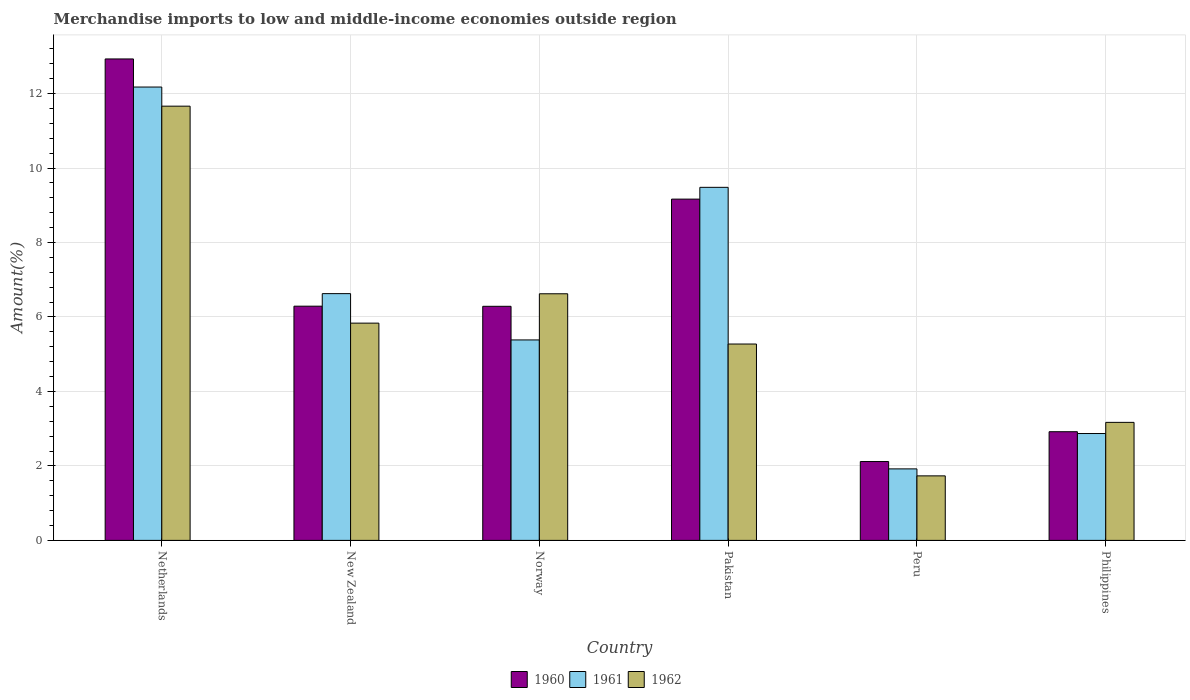How many groups of bars are there?
Make the answer very short. 6. Are the number of bars per tick equal to the number of legend labels?
Your response must be concise. Yes. Are the number of bars on each tick of the X-axis equal?
Make the answer very short. Yes. How many bars are there on the 5th tick from the right?
Your answer should be very brief. 3. In how many cases, is the number of bars for a given country not equal to the number of legend labels?
Your answer should be very brief. 0. What is the percentage of amount earned from merchandise imports in 1960 in Netherlands?
Provide a succinct answer. 12.93. Across all countries, what is the maximum percentage of amount earned from merchandise imports in 1961?
Make the answer very short. 12.18. Across all countries, what is the minimum percentage of amount earned from merchandise imports in 1962?
Ensure brevity in your answer.  1.73. What is the total percentage of amount earned from merchandise imports in 1961 in the graph?
Provide a short and direct response. 38.46. What is the difference between the percentage of amount earned from merchandise imports in 1962 in New Zealand and that in Philippines?
Your answer should be compact. 2.67. What is the difference between the percentage of amount earned from merchandise imports in 1961 in Norway and the percentage of amount earned from merchandise imports in 1962 in Philippines?
Provide a short and direct response. 2.21. What is the average percentage of amount earned from merchandise imports in 1962 per country?
Make the answer very short. 5.72. What is the difference between the percentage of amount earned from merchandise imports of/in 1962 and percentage of amount earned from merchandise imports of/in 1960 in Peru?
Offer a very short reply. -0.39. In how many countries, is the percentage of amount earned from merchandise imports in 1962 greater than 9.6 %?
Keep it short and to the point. 1. What is the ratio of the percentage of amount earned from merchandise imports in 1962 in New Zealand to that in Norway?
Your answer should be compact. 0.88. Is the percentage of amount earned from merchandise imports in 1961 in New Zealand less than that in Pakistan?
Provide a succinct answer. Yes. What is the difference between the highest and the second highest percentage of amount earned from merchandise imports in 1960?
Make the answer very short. -3.76. What is the difference between the highest and the lowest percentage of amount earned from merchandise imports in 1960?
Your answer should be compact. 10.81. In how many countries, is the percentage of amount earned from merchandise imports in 1961 greater than the average percentage of amount earned from merchandise imports in 1961 taken over all countries?
Your response must be concise. 3. What does the 2nd bar from the left in Philippines represents?
Your answer should be compact. 1961. Is it the case that in every country, the sum of the percentage of amount earned from merchandise imports in 1961 and percentage of amount earned from merchandise imports in 1962 is greater than the percentage of amount earned from merchandise imports in 1960?
Provide a succinct answer. Yes. How many bars are there?
Make the answer very short. 18. Does the graph contain grids?
Offer a very short reply. Yes. Where does the legend appear in the graph?
Your answer should be compact. Bottom center. What is the title of the graph?
Your answer should be compact. Merchandise imports to low and middle-income economies outside region. Does "1983" appear as one of the legend labels in the graph?
Provide a succinct answer. No. What is the label or title of the Y-axis?
Provide a short and direct response. Amount(%). What is the Amount(%) in 1960 in Netherlands?
Ensure brevity in your answer.  12.93. What is the Amount(%) of 1961 in Netherlands?
Make the answer very short. 12.18. What is the Amount(%) of 1962 in Netherlands?
Your response must be concise. 11.66. What is the Amount(%) of 1960 in New Zealand?
Your answer should be very brief. 6.29. What is the Amount(%) of 1961 in New Zealand?
Give a very brief answer. 6.63. What is the Amount(%) in 1962 in New Zealand?
Make the answer very short. 5.83. What is the Amount(%) of 1960 in Norway?
Your response must be concise. 6.29. What is the Amount(%) of 1961 in Norway?
Give a very brief answer. 5.38. What is the Amount(%) of 1962 in Norway?
Ensure brevity in your answer.  6.62. What is the Amount(%) in 1960 in Pakistan?
Ensure brevity in your answer.  9.17. What is the Amount(%) in 1961 in Pakistan?
Provide a succinct answer. 9.48. What is the Amount(%) in 1962 in Pakistan?
Ensure brevity in your answer.  5.27. What is the Amount(%) of 1960 in Peru?
Ensure brevity in your answer.  2.12. What is the Amount(%) of 1961 in Peru?
Provide a short and direct response. 1.92. What is the Amount(%) of 1962 in Peru?
Your answer should be very brief. 1.73. What is the Amount(%) of 1960 in Philippines?
Keep it short and to the point. 2.92. What is the Amount(%) in 1961 in Philippines?
Provide a short and direct response. 2.87. What is the Amount(%) of 1962 in Philippines?
Ensure brevity in your answer.  3.17. Across all countries, what is the maximum Amount(%) in 1960?
Give a very brief answer. 12.93. Across all countries, what is the maximum Amount(%) in 1961?
Ensure brevity in your answer.  12.18. Across all countries, what is the maximum Amount(%) of 1962?
Give a very brief answer. 11.66. Across all countries, what is the minimum Amount(%) of 1960?
Offer a very short reply. 2.12. Across all countries, what is the minimum Amount(%) in 1961?
Give a very brief answer. 1.92. Across all countries, what is the minimum Amount(%) of 1962?
Ensure brevity in your answer.  1.73. What is the total Amount(%) of 1960 in the graph?
Your answer should be compact. 39.71. What is the total Amount(%) in 1961 in the graph?
Offer a very short reply. 38.46. What is the total Amount(%) in 1962 in the graph?
Offer a terse response. 34.3. What is the difference between the Amount(%) of 1960 in Netherlands and that in New Zealand?
Provide a succinct answer. 6.64. What is the difference between the Amount(%) of 1961 in Netherlands and that in New Zealand?
Your response must be concise. 5.55. What is the difference between the Amount(%) in 1962 in Netherlands and that in New Zealand?
Make the answer very short. 5.83. What is the difference between the Amount(%) of 1960 in Netherlands and that in Norway?
Offer a very short reply. 6.64. What is the difference between the Amount(%) of 1961 in Netherlands and that in Norway?
Keep it short and to the point. 6.79. What is the difference between the Amount(%) of 1962 in Netherlands and that in Norway?
Keep it short and to the point. 5.04. What is the difference between the Amount(%) of 1960 in Netherlands and that in Pakistan?
Ensure brevity in your answer.  3.76. What is the difference between the Amount(%) of 1961 in Netherlands and that in Pakistan?
Your answer should be compact. 2.69. What is the difference between the Amount(%) in 1962 in Netherlands and that in Pakistan?
Provide a succinct answer. 6.39. What is the difference between the Amount(%) of 1960 in Netherlands and that in Peru?
Your answer should be very brief. 10.81. What is the difference between the Amount(%) in 1961 in Netherlands and that in Peru?
Make the answer very short. 10.26. What is the difference between the Amount(%) in 1962 in Netherlands and that in Peru?
Make the answer very short. 9.93. What is the difference between the Amount(%) in 1960 in Netherlands and that in Philippines?
Ensure brevity in your answer.  10.01. What is the difference between the Amount(%) of 1961 in Netherlands and that in Philippines?
Provide a short and direct response. 9.31. What is the difference between the Amount(%) in 1962 in Netherlands and that in Philippines?
Ensure brevity in your answer.  8.49. What is the difference between the Amount(%) in 1960 in New Zealand and that in Norway?
Offer a very short reply. 0. What is the difference between the Amount(%) of 1961 in New Zealand and that in Norway?
Provide a short and direct response. 1.24. What is the difference between the Amount(%) of 1962 in New Zealand and that in Norway?
Your answer should be compact. -0.79. What is the difference between the Amount(%) in 1960 in New Zealand and that in Pakistan?
Give a very brief answer. -2.88. What is the difference between the Amount(%) of 1961 in New Zealand and that in Pakistan?
Offer a very short reply. -2.86. What is the difference between the Amount(%) in 1962 in New Zealand and that in Pakistan?
Your answer should be compact. 0.56. What is the difference between the Amount(%) of 1960 in New Zealand and that in Peru?
Provide a short and direct response. 4.17. What is the difference between the Amount(%) in 1961 in New Zealand and that in Peru?
Provide a succinct answer. 4.71. What is the difference between the Amount(%) of 1962 in New Zealand and that in Peru?
Your answer should be compact. 4.1. What is the difference between the Amount(%) in 1960 in New Zealand and that in Philippines?
Ensure brevity in your answer.  3.37. What is the difference between the Amount(%) of 1961 in New Zealand and that in Philippines?
Your answer should be very brief. 3.76. What is the difference between the Amount(%) of 1962 in New Zealand and that in Philippines?
Provide a short and direct response. 2.67. What is the difference between the Amount(%) of 1960 in Norway and that in Pakistan?
Your answer should be very brief. -2.88. What is the difference between the Amount(%) in 1961 in Norway and that in Pakistan?
Offer a terse response. -4.1. What is the difference between the Amount(%) in 1962 in Norway and that in Pakistan?
Your answer should be very brief. 1.35. What is the difference between the Amount(%) in 1960 in Norway and that in Peru?
Your answer should be compact. 4.17. What is the difference between the Amount(%) of 1961 in Norway and that in Peru?
Make the answer very short. 3.46. What is the difference between the Amount(%) of 1962 in Norway and that in Peru?
Ensure brevity in your answer.  4.89. What is the difference between the Amount(%) in 1960 in Norway and that in Philippines?
Your answer should be very brief. 3.37. What is the difference between the Amount(%) of 1961 in Norway and that in Philippines?
Provide a short and direct response. 2.51. What is the difference between the Amount(%) in 1962 in Norway and that in Philippines?
Provide a succinct answer. 3.45. What is the difference between the Amount(%) in 1960 in Pakistan and that in Peru?
Offer a terse response. 7.05. What is the difference between the Amount(%) in 1961 in Pakistan and that in Peru?
Give a very brief answer. 7.56. What is the difference between the Amount(%) in 1962 in Pakistan and that in Peru?
Your response must be concise. 3.54. What is the difference between the Amount(%) of 1960 in Pakistan and that in Philippines?
Your answer should be compact. 6.25. What is the difference between the Amount(%) in 1961 in Pakistan and that in Philippines?
Provide a succinct answer. 6.61. What is the difference between the Amount(%) of 1962 in Pakistan and that in Philippines?
Offer a very short reply. 2.1. What is the difference between the Amount(%) of 1960 in Peru and that in Philippines?
Your answer should be compact. -0.8. What is the difference between the Amount(%) of 1961 in Peru and that in Philippines?
Ensure brevity in your answer.  -0.95. What is the difference between the Amount(%) of 1962 in Peru and that in Philippines?
Provide a short and direct response. -1.44. What is the difference between the Amount(%) in 1960 in Netherlands and the Amount(%) in 1961 in New Zealand?
Your answer should be very brief. 6.3. What is the difference between the Amount(%) of 1960 in Netherlands and the Amount(%) of 1962 in New Zealand?
Provide a succinct answer. 7.1. What is the difference between the Amount(%) in 1961 in Netherlands and the Amount(%) in 1962 in New Zealand?
Your answer should be compact. 6.34. What is the difference between the Amount(%) in 1960 in Netherlands and the Amount(%) in 1961 in Norway?
Provide a short and direct response. 7.55. What is the difference between the Amount(%) in 1960 in Netherlands and the Amount(%) in 1962 in Norway?
Provide a short and direct response. 6.31. What is the difference between the Amount(%) in 1961 in Netherlands and the Amount(%) in 1962 in Norway?
Keep it short and to the point. 5.55. What is the difference between the Amount(%) in 1960 in Netherlands and the Amount(%) in 1961 in Pakistan?
Ensure brevity in your answer.  3.45. What is the difference between the Amount(%) in 1960 in Netherlands and the Amount(%) in 1962 in Pakistan?
Keep it short and to the point. 7.66. What is the difference between the Amount(%) in 1961 in Netherlands and the Amount(%) in 1962 in Pakistan?
Give a very brief answer. 6.9. What is the difference between the Amount(%) of 1960 in Netherlands and the Amount(%) of 1961 in Peru?
Provide a succinct answer. 11.01. What is the difference between the Amount(%) in 1960 in Netherlands and the Amount(%) in 1962 in Peru?
Your response must be concise. 11.2. What is the difference between the Amount(%) in 1961 in Netherlands and the Amount(%) in 1962 in Peru?
Make the answer very short. 10.44. What is the difference between the Amount(%) in 1960 in Netherlands and the Amount(%) in 1961 in Philippines?
Offer a very short reply. 10.06. What is the difference between the Amount(%) of 1960 in Netherlands and the Amount(%) of 1962 in Philippines?
Make the answer very short. 9.76. What is the difference between the Amount(%) in 1961 in Netherlands and the Amount(%) in 1962 in Philippines?
Offer a very short reply. 9.01. What is the difference between the Amount(%) of 1960 in New Zealand and the Amount(%) of 1961 in Norway?
Offer a terse response. 0.91. What is the difference between the Amount(%) in 1960 in New Zealand and the Amount(%) in 1962 in Norway?
Offer a very short reply. -0.33. What is the difference between the Amount(%) in 1961 in New Zealand and the Amount(%) in 1962 in Norway?
Offer a very short reply. 0. What is the difference between the Amount(%) of 1960 in New Zealand and the Amount(%) of 1961 in Pakistan?
Ensure brevity in your answer.  -3.19. What is the difference between the Amount(%) of 1960 in New Zealand and the Amount(%) of 1962 in Pakistan?
Offer a terse response. 1.02. What is the difference between the Amount(%) in 1961 in New Zealand and the Amount(%) in 1962 in Pakistan?
Offer a very short reply. 1.35. What is the difference between the Amount(%) of 1960 in New Zealand and the Amount(%) of 1961 in Peru?
Give a very brief answer. 4.37. What is the difference between the Amount(%) in 1960 in New Zealand and the Amount(%) in 1962 in Peru?
Your answer should be very brief. 4.56. What is the difference between the Amount(%) in 1961 in New Zealand and the Amount(%) in 1962 in Peru?
Offer a terse response. 4.89. What is the difference between the Amount(%) of 1960 in New Zealand and the Amount(%) of 1961 in Philippines?
Make the answer very short. 3.42. What is the difference between the Amount(%) in 1960 in New Zealand and the Amount(%) in 1962 in Philippines?
Your response must be concise. 3.12. What is the difference between the Amount(%) in 1961 in New Zealand and the Amount(%) in 1962 in Philippines?
Keep it short and to the point. 3.46. What is the difference between the Amount(%) of 1960 in Norway and the Amount(%) of 1961 in Pakistan?
Provide a short and direct response. -3.2. What is the difference between the Amount(%) of 1961 in Norway and the Amount(%) of 1962 in Pakistan?
Your answer should be compact. 0.11. What is the difference between the Amount(%) in 1960 in Norway and the Amount(%) in 1961 in Peru?
Your answer should be compact. 4.37. What is the difference between the Amount(%) of 1960 in Norway and the Amount(%) of 1962 in Peru?
Ensure brevity in your answer.  4.55. What is the difference between the Amount(%) in 1961 in Norway and the Amount(%) in 1962 in Peru?
Give a very brief answer. 3.65. What is the difference between the Amount(%) of 1960 in Norway and the Amount(%) of 1961 in Philippines?
Ensure brevity in your answer.  3.42. What is the difference between the Amount(%) in 1960 in Norway and the Amount(%) in 1962 in Philippines?
Offer a terse response. 3.12. What is the difference between the Amount(%) in 1961 in Norway and the Amount(%) in 1962 in Philippines?
Provide a short and direct response. 2.21. What is the difference between the Amount(%) in 1960 in Pakistan and the Amount(%) in 1961 in Peru?
Your response must be concise. 7.25. What is the difference between the Amount(%) in 1960 in Pakistan and the Amount(%) in 1962 in Peru?
Offer a terse response. 7.43. What is the difference between the Amount(%) of 1961 in Pakistan and the Amount(%) of 1962 in Peru?
Ensure brevity in your answer.  7.75. What is the difference between the Amount(%) of 1960 in Pakistan and the Amount(%) of 1961 in Philippines?
Offer a very short reply. 6.3. What is the difference between the Amount(%) in 1960 in Pakistan and the Amount(%) in 1962 in Philippines?
Provide a short and direct response. 6. What is the difference between the Amount(%) of 1961 in Pakistan and the Amount(%) of 1962 in Philippines?
Offer a terse response. 6.31. What is the difference between the Amount(%) of 1960 in Peru and the Amount(%) of 1961 in Philippines?
Offer a terse response. -0.75. What is the difference between the Amount(%) in 1960 in Peru and the Amount(%) in 1962 in Philippines?
Make the answer very short. -1.05. What is the difference between the Amount(%) in 1961 in Peru and the Amount(%) in 1962 in Philippines?
Offer a very short reply. -1.25. What is the average Amount(%) in 1960 per country?
Keep it short and to the point. 6.62. What is the average Amount(%) in 1961 per country?
Provide a succinct answer. 6.41. What is the average Amount(%) in 1962 per country?
Your answer should be compact. 5.72. What is the difference between the Amount(%) of 1960 and Amount(%) of 1961 in Netherlands?
Offer a very short reply. 0.75. What is the difference between the Amount(%) of 1960 and Amount(%) of 1962 in Netherlands?
Keep it short and to the point. 1.27. What is the difference between the Amount(%) of 1961 and Amount(%) of 1962 in Netherlands?
Offer a very short reply. 0.51. What is the difference between the Amount(%) in 1960 and Amount(%) in 1961 in New Zealand?
Your answer should be very brief. -0.34. What is the difference between the Amount(%) in 1960 and Amount(%) in 1962 in New Zealand?
Keep it short and to the point. 0.46. What is the difference between the Amount(%) of 1961 and Amount(%) of 1962 in New Zealand?
Provide a short and direct response. 0.79. What is the difference between the Amount(%) of 1960 and Amount(%) of 1961 in Norway?
Your response must be concise. 0.9. What is the difference between the Amount(%) of 1960 and Amount(%) of 1962 in Norway?
Offer a very short reply. -0.34. What is the difference between the Amount(%) in 1961 and Amount(%) in 1962 in Norway?
Keep it short and to the point. -1.24. What is the difference between the Amount(%) of 1960 and Amount(%) of 1961 in Pakistan?
Make the answer very short. -0.32. What is the difference between the Amount(%) of 1960 and Amount(%) of 1962 in Pakistan?
Offer a very short reply. 3.89. What is the difference between the Amount(%) of 1961 and Amount(%) of 1962 in Pakistan?
Your answer should be very brief. 4.21. What is the difference between the Amount(%) in 1960 and Amount(%) in 1961 in Peru?
Your answer should be very brief. 0.2. What is the difference between the Amount(%) of 1960 and Amount(%) of 1962 in Peru?
Give a very brief answer. 0.39. What is the difference between the Amount(%) in 1961 and Amount(%) in 1962 in Peru?
Offer a terse response. 0.19. What is the difference between the Amount(%) in 1960 and Amount(%) in 1961 in Philippines?
Make the answer very short. 0.05. What is the difference between the Amount(%) in 1960 and Amount(%) in 1962 in Philippines?
Your response must be concise. -0.25. What is the difference between the Amount(%) of 1961 and Amount(%) of 1962 in Philippines?
Your answer should be very brief. -0.3. What is the ratio of the Amount(%) in 1960 in Netherlands to that in New Zealand?
Offer a terse response. 2.06. What is the ratio of the Amount(%) of 1961 in Netherlands to that in New Zealand?
Provide a succinct answer. 1.84. What is the ratio of the Amount(%) of 1962 in Netherlands to that in New Zealand?
Offer a very short reply. 2. What is the ratio of the Amount(%) in 1960 in Netherlands to that in Norway?
Provide a short and direct response. 2.06. What is the ratio of the Amount(%) of 1961 in Netherlands to that in Norway?
Your answer should be very brief. 2.26. What is the ratio of the Amount(%) of 1962 in Netherlands to that in Norway?
Keep it short and to the point. 1.76. What is the ratio of the Amount(%) of 1960 in Netherlands to that in Pakistan?
Provide a short and direct response. 1.41. What is the ratio of the Amount(%) of 1961 in Netherlands to that in Pakistan?
Provide a succinct answer. 1.28. What is the ratio of the Amount(%) in 1962 in Netherlands to that in Pakistan?
Provide a succinct answer. 2.21. What is the ratio of the Amount(%) of 1960 in Netherlands to that in Peru?
Your response must be concise. 6.11. What is the ratio of the Amount(%) of 1961 in Netherlands to that in Peru?
Your answer should be compact. 6.34. What is the ratio of the Amount(%) in 1962 in Netherlands to that in Peru?
Provide a succinct answer. 6.73. What is the ratio of the Amount(%) in 1960 in Netherlands to that in Philippines?
Your answer should be very brief. 4.43. What is the ratio of the Amount(%) of 1961 in Netherlands to that in Philippines?
Provide a succinct answer. 4.24. What is the ratio of the Amount(%) in 1962 in Netherlands to that in Philippines?
Your answer should be compact. 3.68. What is the ratio of the Amount(%) in 1961 in New Zealand to that in Norway?
Your answer should be compact. 1.23. What is the ratio of the Amount(%) of 1962 in New Zealand to that in Norway?
Offer a very short reply. 0.88. What is the ratio of the Amount(%) of 1960 in New Zealand to that in Pakistan?
Offer a terse response. 0.69. What is the ratio of the Amount(%) in 1961 in New Zealand to that in Pakistan?
Your response must be concise. 0.7. What is the ratio of the Amount(%) of 1962 in New Zealand to that in Pakistan?
Offer a very short reply. 1.11. What is the ratio of the Amount(%) in 1960 in New Zealand to that in Peru?
Offer a very short reply. 2.97. What is the ratio of the Amount(%) of 1961 in New Zealand to that in Peru?
Make the answer very short. 3.45. What is the ratio of the Amount(%) of 1962 in New Zealand to that in Peru?
Provide a short and direct response. 3.37. What is the ratio of the Amount(%) in 1960 in New Zealand to that in Philippines?
Give a very brief answer. 2.16. What is the ratio of the Amount(%) of 1961 in New Zealand to that in Philippines?
Your answer should be very brief. 2.31. What is the ratio of the Amount(%) of 1962 in New Zealand to that in Philippines?
Make the answer very short. 1.84. What is the ratio of the Amount(%) of 1960 in Norway to that in Pakistan?
Make the answer very short. 0.69. What is the ratio of the Amount(%) in 1961 in Norway to that in Pakistan?
Your response must be concise. 0.57. What is the ratio of the Amount(%) in 1962 in Norway to that in Pakistan?
Offer a terse response. 1.26. What is the ratio of the Amount(%) in 1960 in Norway to that in Peru?
Your answer should be compact. 2.97. What is the ratio of the Amount(%) in 1961 in Norway to that in Peru?
Offer a very short reply. 2.8. What is the ratio of the Amount(%) in 1962 in Norway to that in Peru?
Ensure brevity in your answer.  3.82. What is the ratio of the Amount(%) in 1960 in Norway to that in Philippines?
Provide a short and direct response. 2.15. What is the ratio of the Amount(%) in 1961 in Norway to that in Philippines?
Your response must be concise. 1.88. What is the ratio of the Amount(%) of 1962 in Norway to that in Philippines?
Your answer should be very brief. 2.09. What is the ratio of the Amount(%) of 1960 in Pakistan to that in Peru?
Your response must be concise. 4.33. What is the ratio of the Amount(%) in 1961 in Pakistan to that in Peru?
Provide a succinct answer. 4.94. What is the ratio of the Amount(%) of 1962 in Pakistan to that in Peru?
Keep it short and to the point. 3.04. What is the ratio of the Amount(%) of 1960 in Pakistan to that in Philippines?
Offer a terse response. 3.14. What is the ratio of the Amount(%) of 1961 in Pakistan to that in Philippines?
Make the answer very short. 3.3. What is the ratio of the Amount(%) of 1962 in Pakistan to that in Philippines?
Keep it short and to the point. 1.66. What is the ratio of the Amount(%) in 1960 in Peru to that in Philippines?
Provide a short and direct response. 0.73. What is the ratio of the Amount(%) in 1961 in Peru to that in Philippines?
Provide a succinct answer. 0.67. What is the ratio of the Amount(%) in 1962 in Peru to that in Philippines?
Ensure brevity in your answer.  0.55. What is the difference between the highest and the second highest Amount(%) of 1960?
Give a very brief answer. 3.76. What is the difference between the highest and the second highest Amount(%) of 1961?
Make the answer very short. 2.69. What is the difference between the highest and the second highest Amount(%) of 1962?
Provide a short and direct response. 5.04. What is the difference between the highest and the lowest Amount(%) in 1960?
Make the answer very short. 10.81. What is the difference between the highest and the lowest Amount(%) in 1961?
Ensure brevity in your answer.  10.26. What is the difference between the highest and the lowest Amount(%) in 1962?
Provide a succinct answer. 9.93. 